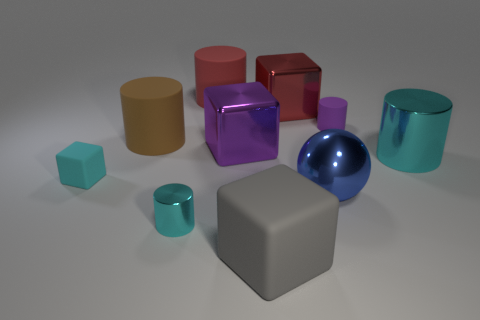Are there an equal number of big metallic cylinders in front of the gray matte cube and big metal spheres that are on the left side of the big metallic sphere?
Give a very brief answer. Yes. How many tiny blue matte spheres are there?
Your answer should be very brief. 0. Is the number of large shiny blocks that are on the left side of the big cyan shiny cylinder greater than the number of big blue shiny things?
Keep it short and to the point. Yes. There is a tiny cyan block in front of the tiny rubber cylinder; what material is it?
Your answer should be very brief. Rubber. What is the color of the other metallic thing that is the same shape as the tiny shiny object?
Make the answer very short. Cyan. How many cubes have the same color as the tiny shiny cylinder?
Provide a short and direct response. 1. There is a cyan shiny cylinder in front of the big ball; is it the same size as the thing that is left of the brown rubber cylinder?
Offer a very short reply. Yes. There is a purple rubber thing; is its size the same as the cyan cylinder that is in front of the small cyan block?
Give a very brief answer. Yes. The purple metal block is what size?
Your answer should be very brief. Large. What is the color of the tiny thing that is the same material as the large blue ball?
Make the answer very short. Cyan. 